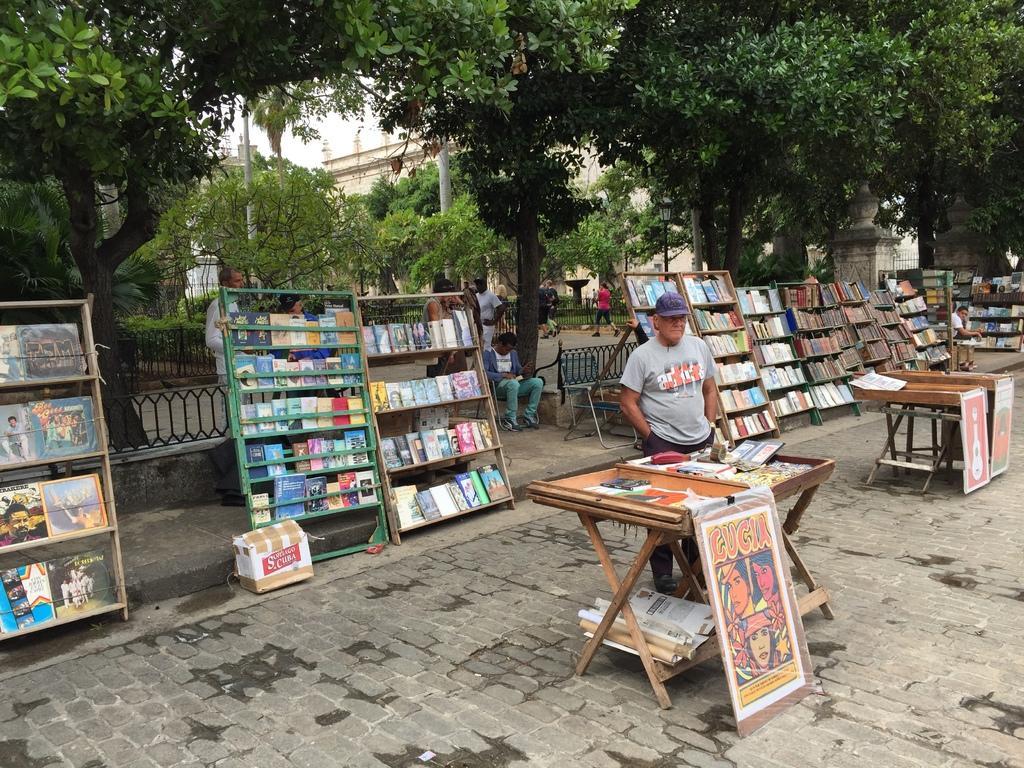How would you summarize this image in a sentence or two? In this picture we can see man standing beside table and on table we have cards, papers, banners and in background we can see books in racks, benches, tree, building, pole, fence. 